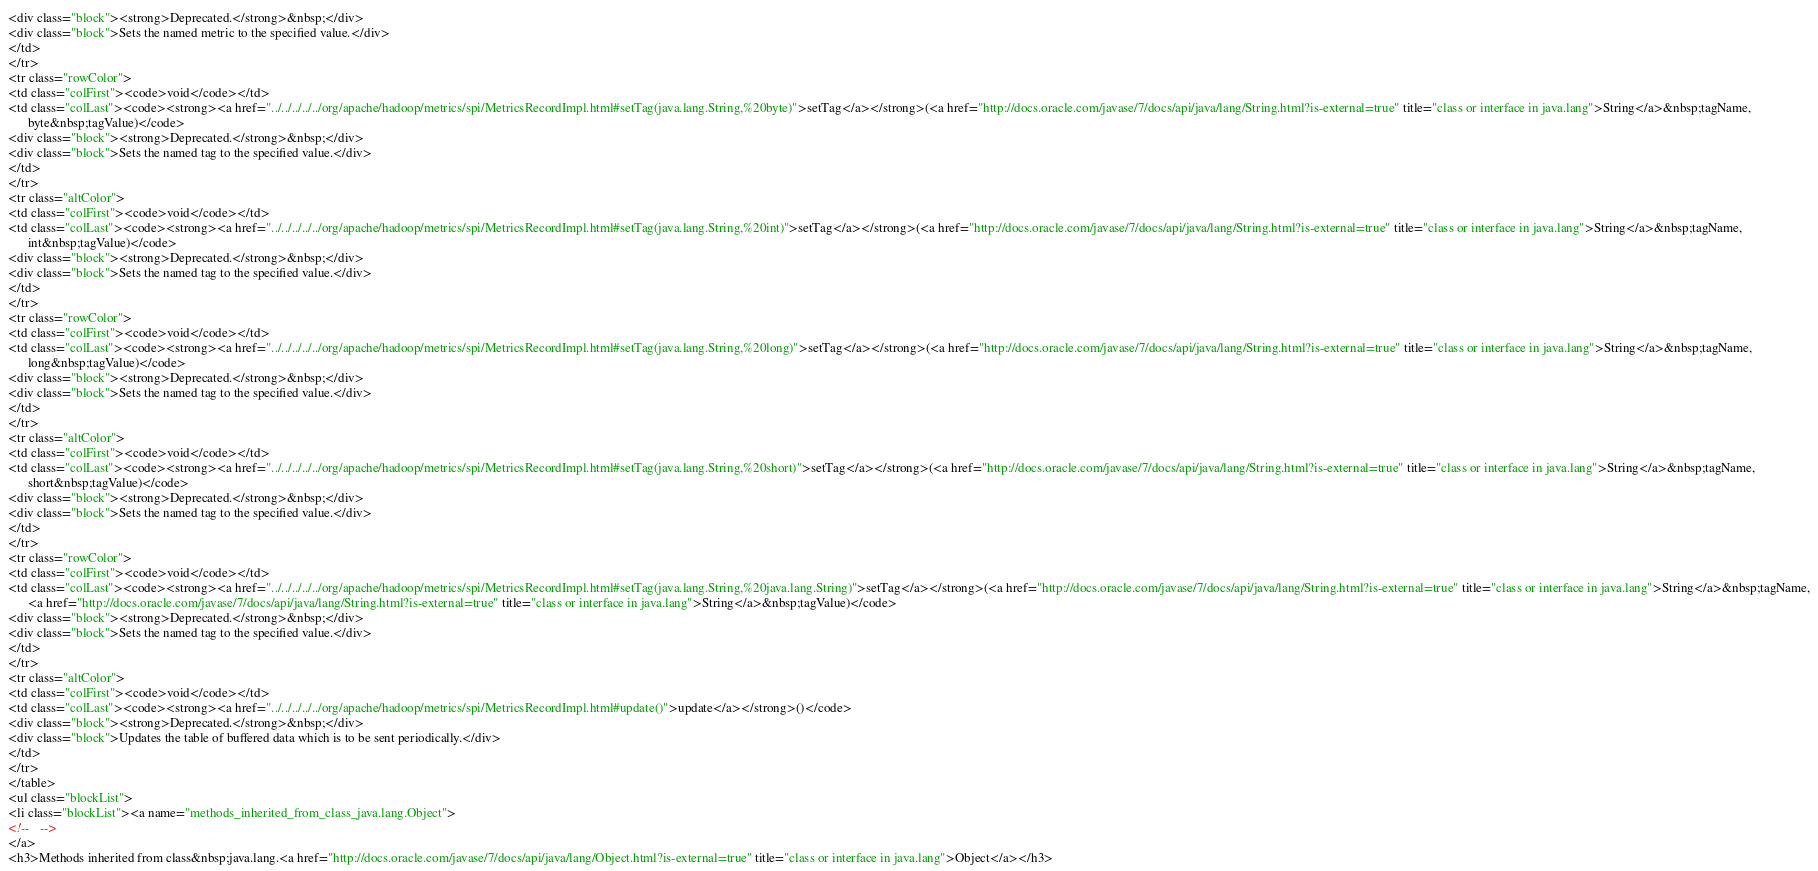Convert code to text. <code><loc_0><loc_0><loc_500><loc_500><_HTML_><div class="block"><strong>Deprecated.</strong>&nbsp;</div>
<div class="block">Sets the named metric to the specified value.</div>
</td>
</tr>
<tr class="rowColor">
<td class="colFirst"><code>void</code></td>
<td class="colLast"><code><strong><a href="../../../../../org/apache/hadoop/metrics/spi/MetricsRecordImpl.html#setTag(java.lang.String,%20byte)">setTag</a></strong>(<a href="http://docs.oracle.com/javase/7/docs/api/java/lang/String.html?is-external=true" title="class or interface in java.lang">String</a>&nbsp;tagName,
      byte&nbsp;tagValue)</code>
<div class="block"><strong>Deprecated.</strong>&nbsp;</div>
<div class="block">Sets the named tag to the specified value.</div>
</td>
</tr>
<tr class="altColor">
<td class="colFirst"><code>void</code></td>
<td class="colLast"><code><strong><a href="../../../../../org/apache/hadoop/metrics/spi/MetricsRecordImpl.html#setTag(java.lang.String,%20int)">setTag</a></strong>(<a href="http://docs.oracle.com/javase/7/docs/api/java/lang/String.html?is-external=true" title="class or interface in java.lang">String</a>&nbsp;tagName,
      int&nbsp;tagValue)</code>
<div class="block"><strong>Deprecated.</strong>&nbsp;</div>
<div class="block">Sets the named tag to the specified value.</div>
</td>
</tr>
<tr class="rowColor">
<td class="colFirst"><code>void</code></td>
<td class="colLast"><code><strong><a href="../../../../../org/apache/hadoop/metrics/spi/MetricsRecordImpl.html#setTag(java.lang.String,%20long)">setTag</a></strong>(<a href="http://docs.oracle.com/javase/7/docs/api/java/lang/String.html?is-external=true" title="class or interface in java.lang">String</a>&nbsp;tagName,
      long&nbsp;tagValue)</code>
<div class="block"><strong>Deprecated.</strong>&nbsp;</div>
<div class="block">Sets the named tag to the specified value.</div>
</td>
</tr>
<tr class="altColor">
<td class="colFirst"><code>void</code></td>
<td class="colLast"><code><strong><a href="../../../../../org/apache/hadoop/metrics/spi/MetricsRecordImpl.html#setTag(java.lang.String,%20short)">setTag</a></strong>(<a href="http://docs.oracle.com/javase/7/docs/api/java/lang/String.html?is-external=true" title="class or interface in java.lang">String</a>&nbsp;tagName,
      short&nbsp;tagValue)</code>
<div class="block"><strong>Deprecated.</strong>&nbsp;</div>
<div class="block">Sets the named tag to the specified value.</div>
</td>
</tr>
<tr class="rowColor">
<td class="colFirst"><code>void</code></td>
<td class="colLast"><code><strong><a href="../../../../../org/apache/hadoop/metrics/spi/MetricsRecordImpl.html#setTag(java.lang.String,%20java.lang.String)">setTag</a></strong>(<a href="http://docs.oracle.com/javase/7/docs/api/java/lang/String.html?is-external=true" title="class or interface in java.lang">String</a>&nbsp;tagName,
      <a href="http://docs.oracle.com/javase/7/docs/api/java/lang/String.html?is-external=true" title="class or interface in java.lang">String</a>&nbsp;tagValue)</code>
<div class="block"><strong>Deprecated.</strong>&nbsp;</div>
<div class="block">Sets the named tag to the specified value.</div>
</td>
</tr>
<tr class="altColor">
<td class="colFirst"><code>void</code></td>
<td class="colLast"><code><strong><a href="../../../../../org/apache/hadoop/metrics/spi/MetricsRecordImpl.html#update()">update</a></strong>()</code>
<div class="block"><strong>Deprecated.</strong>&nbsp;</div>
<div class="block">Updates the table of buffered data which is to be sent periodically.</div>
</td>
</tr>
</table>
<ul class="blockList">
<li class="blockList"><a name="methods_inherited_from_class_java.lang.Object">
<!--   -->
</a>
<h3>Methods inherited from class&nbsp;java.lang.<a href="http://docs.oracle.com/javase/7/docs/api/java/lang/Object.html?is-external=true" title="class or interface in java.lang">Object</a></h3></code> 